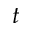<formula> <loc_0><loc_0><loc_500><loc_500>t</formula> 